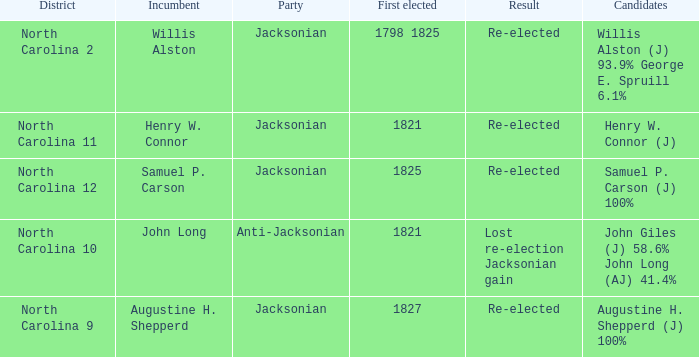Identify the consequence of the first elected event that took place from 1798 to 1825. Re-elected. 